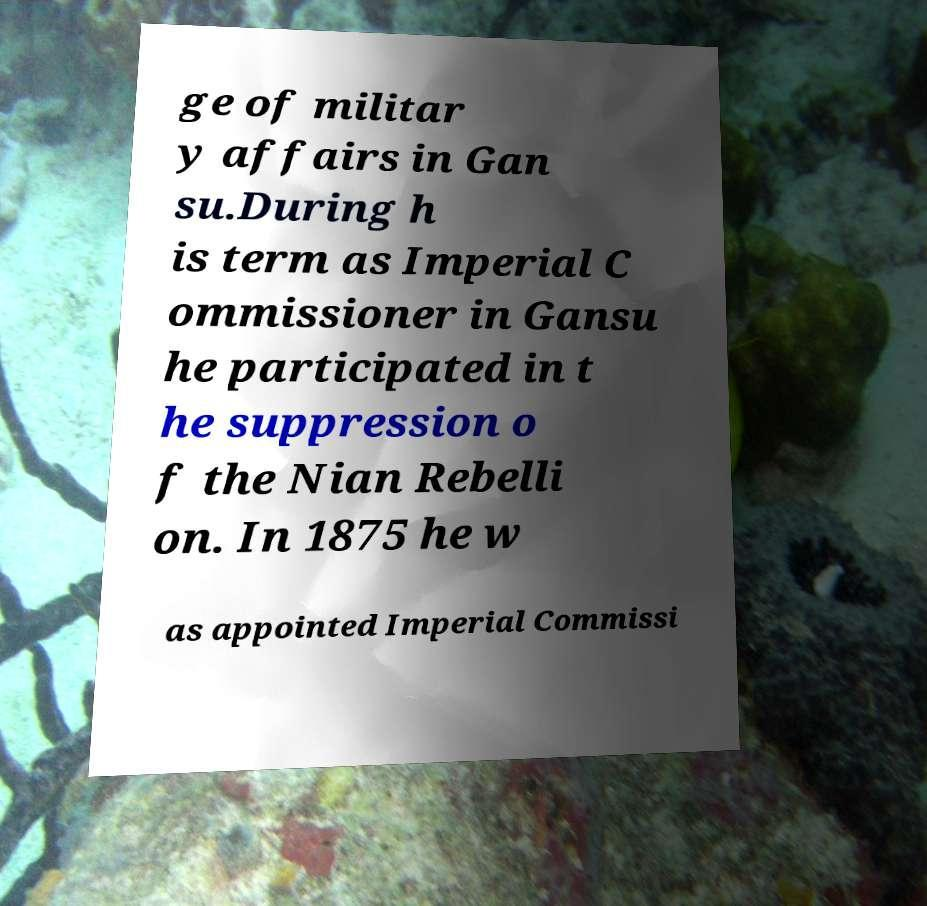For documentation purposes, I need the text within this image transcribed. Could you provide that? ge of militar y affairs in Gan su.During h is term as Imperial C ommissioner in Gansu he participated in t he suppression o f the Nian Rebelli on. In 1875 he w as appointed Imperial Commissi 